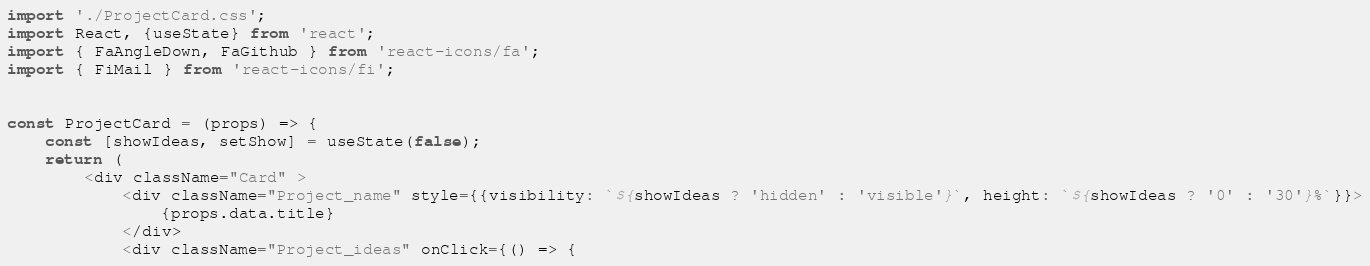<code> <loc_0><loc_0><loc_500><loc_500><_JavaScript_>import './ProjectCard.css';
import React, {useState} from 'react';
import { FaAngleDown, FaGithub } from 'react-icons/fa';
import { FiMail } from 'react-icons/fi';


const ProjectCard = (props) => {
    const [showIdeas, setShow] = useState(false);
    return (
        <div className="Card" >
            <div className="Project_name" style={{visibility: `${showIdeas ? 'hidden' : 'visible'}`, height: `${showIdeas ? '0' : '30'}%`}}>
                {props.data.title}
            </div>
            <div className="Project_ideas" onClick={() => {</code> 